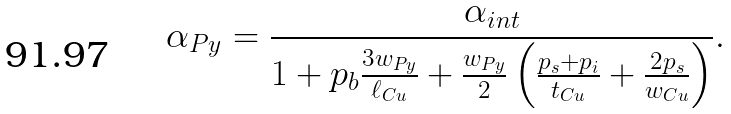<formula> <loc_0><loc_0><loc_500><loc_500>\alpha _ { P y } = \frac { \alpha _ { i n t } } { 1 + p _ { b } \frac { 3 w _ { P y } } { \ell _ { C u } } + \frac { w _ { P y } } { 2 } \left ( \frac { p _ { s } + p _ { i } } { t _ { C u } } + \frac { 2 p _ { s } } { w _ { C u } } \right ) } .</formula> 